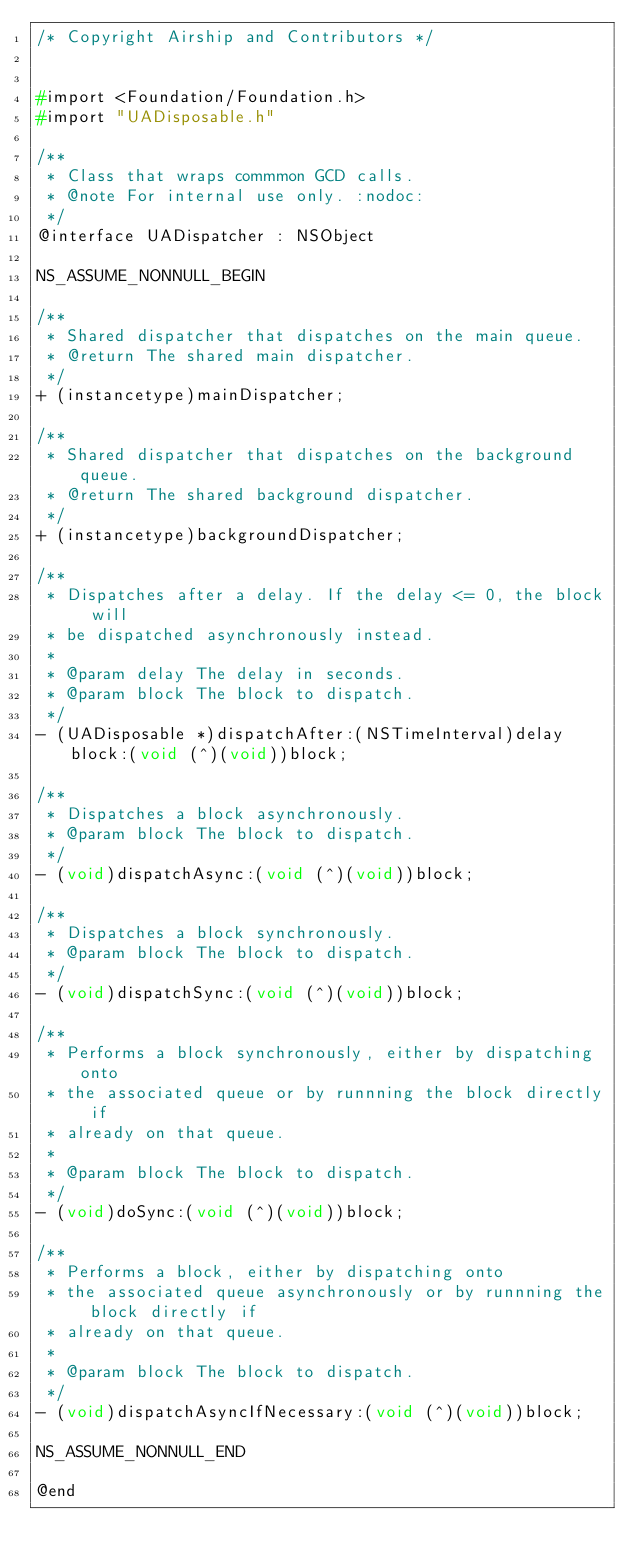<code> <loc_0><loc_0><loc_500><loc_500><_C_>/* Copyright Airship and Contributors */


#import <Foundation/Foundation.h>
#import "UADisposable.h"

/**
 * Class that wraps commmon GCD calls.
 * @note For internal use only. :nodoc:
 */
@interface UADispatcher : NSObject

NS_ASSUME_NONNULL_BEGIN

/**
 * Shared dispatcher that dispatches on the main queue.
 * @return The shared main dispatcher.
 */
+ (instancetype)mainDispatcher;

/**
 * Shared dispatcher that dispatches on the background queue.
 * @return The shared background dispatcher.
 */
+ (instancetype)backgroundDispatcher;

/**
 * Dispatches after a delay. If the delay <= 0, the block will
 * be dispatched asynchronously instead.
 *
 * @param delay The delay in seconds.
 * @param block The block to dispatch.
 */
- (UADisposable *)dispatchAfter:(NSTimeInterval)delay block:(void (^)(void))block;

/**
 * Dispatches a block asynchronously.
 * @param block The block to dispatch.
 */
- (void)dispatchAsync:(void (^)(void))block;

/**
 * Dispatches a block synchronously.
 * @param block The block to dispatch.
 */
- (void)dispatchSync:(void (^)(void))block;

/**
 * Performs a block synchronously, either by dispatching onto
 * the associated queue or by runnning the block directly if
 * already on that queue.
 *
 * @param block The block to dispatch.
 */
- (void)doSync:(void (^)(void))block;

/**
 * Performs a block, either by dispatching onto
 * the associated queue asynchronously or by runnning the block directly if
 * already on that queue.
 *
 * @param block The block to dispatch.
 */
- (void)dispatchAsyncIfNecessary:(void (^)(void))block;

NS_ASSUME_NONNULL_END

@end
</code> 